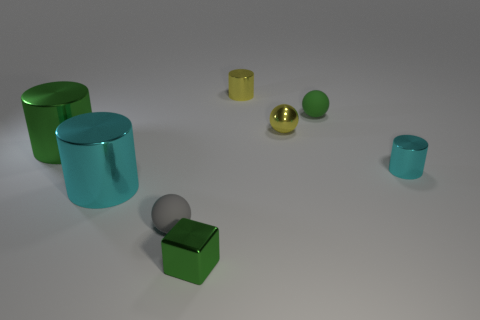Does the cyan thing on the left side of the tiny gray object have the same material as the cube?
Your answer should be very brief. Yes. There is a small matte thing that is behind the ball on the left side of the small yellow metallic cylinder; is there a ball that is left of it?
Make the answer very short. Yes. How many spheres are either tiny cyan objects or cyan metal things?
Keep it short and to the point. 0. There is a tiny green object that is behind the tiny gray object; what is its material?
Offer a very short reply. Rubber. There is a sphere that is the same color as the small metallic cube; what is its size?
Make the answer very short. Small. There is a metallic cylinder right of the tiny yellow metal cylinder; is its color the same as the big cylinder that is in front of the green metal cylinder?
Offer a terse response. Yes. What number of objects are cyan things or cylinders?
Your answer should be compact. 4. What number of other objects are the same shape as the small green shiny thing?
Provide a succinct answer. 0. Are the tiny object in front of the tiny gray rubber thing and the small yellow cylinder to the left of the yellow metallic sphere made of the same material?
Provide a succinct answer. Yes. What shape is the small object that is both in front of the large green shiny cylinder and to the right of the green cube?
Offer a very short reply. Cylinder. 